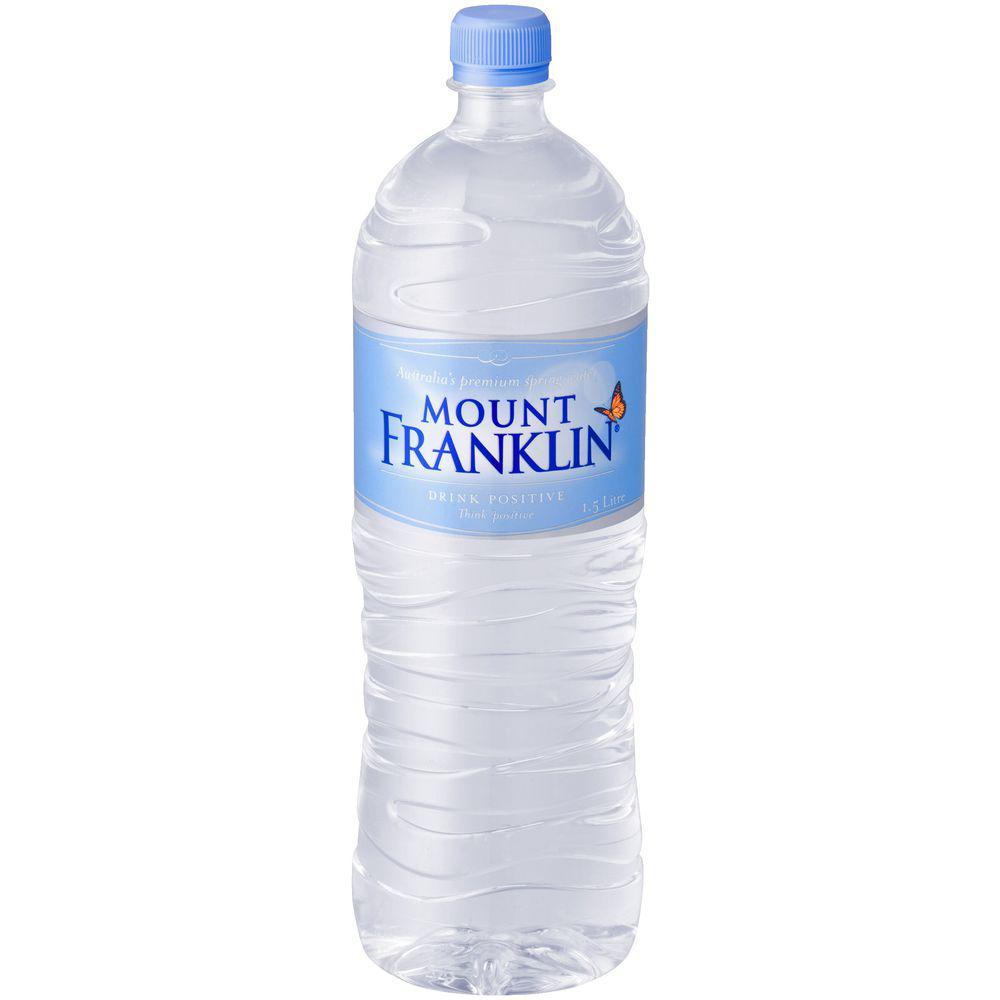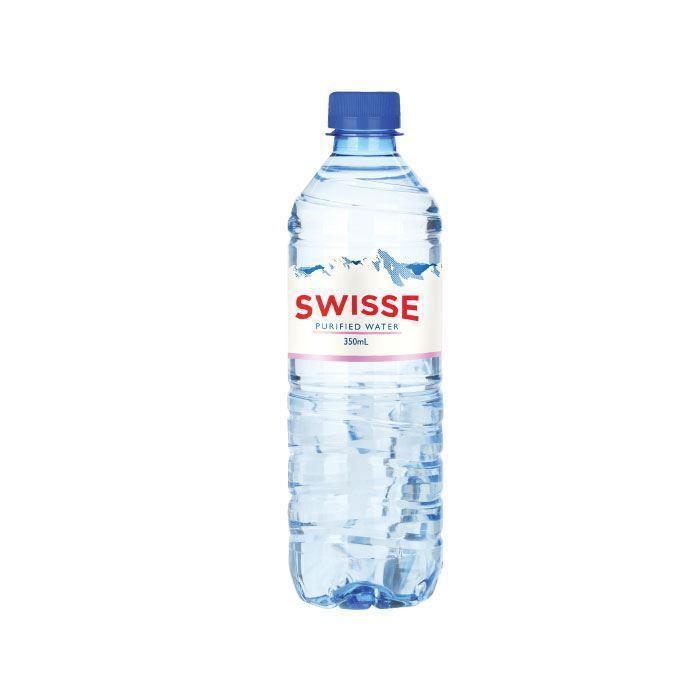The first image is the image on the left, the second image is the image on the right. Evaluate the accuracy of this statement regarding the images: "At least one of the bottles doesn't have a lable.". Is it true? Answer yes or no. No. The first image is the image on the left, the second image is the image on the right. Evaluate the accuracy of this statement regarding the images: "Each image contains exactly one water bottle with a blue lid.". Is it true? Answer yes or no. Yes. 